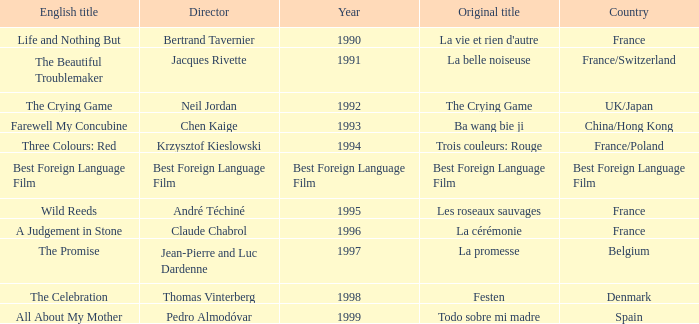Which Country is listed for the Director Thomas Vinterberg? Denmark. 